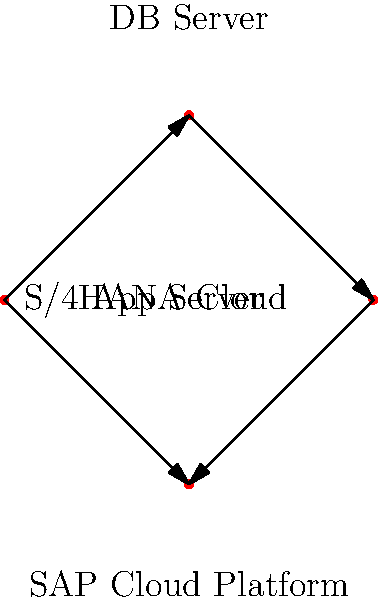In the context of modern cloud-based SAP systems, which component acts as the central hub for data processing and integration in this network topology? To determine the central hub for data processing and integration in this network topology for modern cloud-based SAP systems, let's analyze the components and their connections:

1. App Server: This is the entry point for user interactions and application logic.
2. DB Server: This manages the database operations and storage.
3. S/4HANA Cloud: This is SAP's cloud-based ERP solution.
4. SAP Cloud Platform: This is the platform-as-a-service (PaaS) offering from SAP.

Examining the connections:
- The App Server is connected to both the DB Server and SAP Cloud Platform.
- The DB Server is connected to S/4HANA Cloud.
- S/4HANA Cloud is also connected to SAP Cloud Platform.

The SAP Cloud Platform stands out as the central component in this topology because:
1. It has direct connections to both the App Server and S/4HANA Cloud.
2. It serves as an integration platform for various SAP and non-SAP applications.
3. It provides services for data processing, analytics, and application development.
4. It enables seamless communication between on-premise systems (represented by the App Server and DB Server) and cloud solutions (S/4HANA Cloud).

Therefore, the SAP Cloud Platform acts as the central hub for data processing and integration in this network topology of modern cloud-based SAP systems.
Answer: SAP Cloud Platform 